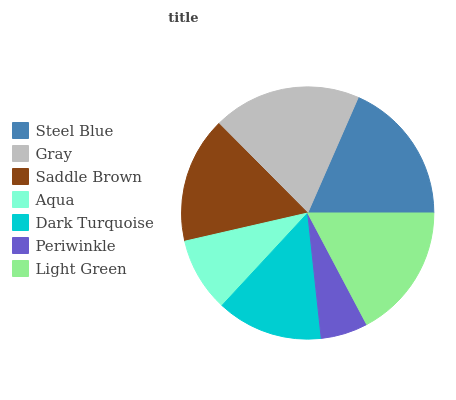Is Periwinkle the minimum?
Answer yes or no. Yes. Is Gray the maximum?
Answer yes or no. Yes. Is Saddle Brown the minimum?
Answer yes or no. No. Is Saddle Brown the maximum?
Answer yes or no. No. Is Gray greater than Saddle Brown?
Answer yes or no. Yes. Is Saddle Brown less than Gray?
Answer yes or no. Yes. Is Saddle Brown greater than Gray?
Answer yes or no. No. Is Gray less than Saddle Brown?
Answer yes or no. No. Is Saddle Brown the high median?
Answer yes or no. Yes. Is Saddle Brown the low median?
Answer yes or no. Yes. Is Aqua the high median?
Answer yes or no. No. Is Dark Turquoise the low median?
Answer yes or no. No. 